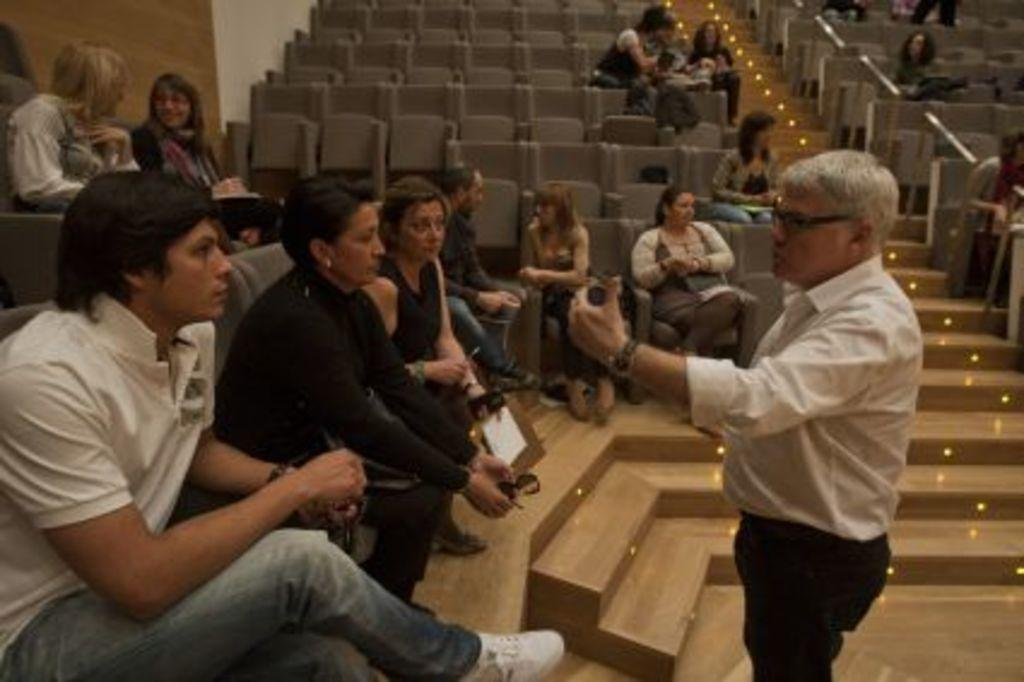What are the people in the image doing? The people in the image are sitting on chairs. Can you describe the man in the image? There is a man standing in front of the people in the image. What feature can be seen on the stairs in the image? There are lightings on the stairs in the image. What type of straw is being used by the people in the image? There is no straw present in the image. 